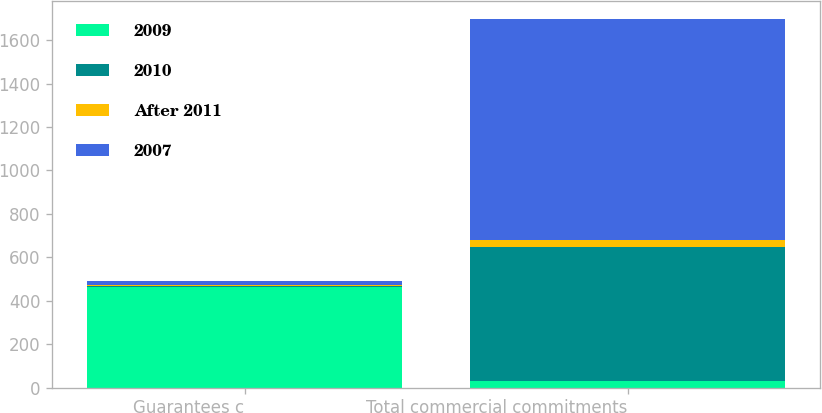<chart> <loc_0><loc_0><loc_500><loc_500><stacked_bar_chart><ecel><fcel>Guarantees c<fcel>Total commercial commitments<nl><fcel>2009<fcel>464<fcel>31<nl><fcel>2010<fcel>5<fcel>617<nl><fcel>After 2011<fcel>6<fcel>31<nl><fcel>2007<fcel>18<fcel>1018<nl></chart> 